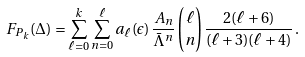<formula> <loc_0><loc_0><loc_500><loc_500>F _ { P _ { k } } ( \Delta ) = \sum _ { \ell = 0 } ^ { k } \sum _ { n = 0 } ^ { \ell } a _ { \ell } ( \epsilon ) \, { \frac { A _ { n } } { \bar { \Lambda } ^ { n } } } \, { \binom { \ell } { n } } \, { \frac { 2 ( \ell + 6 ) } { ( \ell + 3 ) ( \ell + 4 ) } } \, .</formula> 